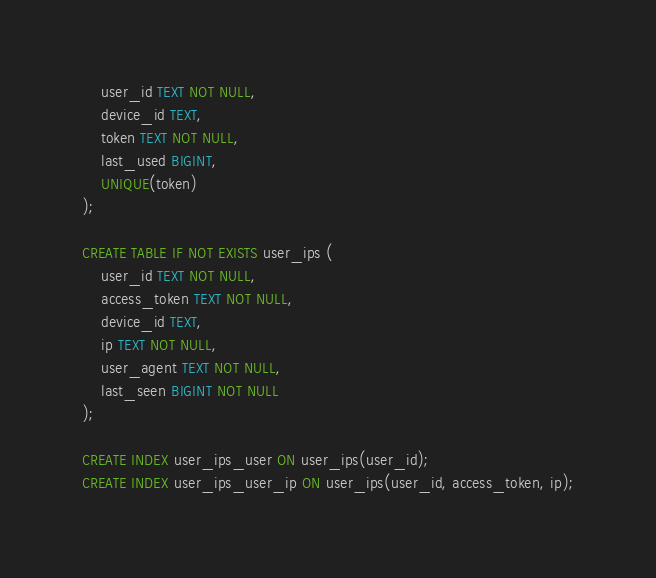Convert code to text. <code><loc_0><loc_0><loc_500><loc_500><_SQL_>    user_id TEXT NOT NULL,
    device_id TEXT,
    token TEXT NOT NULL,
    last_used BIGINT,
    UNIQUE(token)
);

CREATE TABLE IF NOT EXISTS user_ips (
    user_id TEXT NOT NULL,
    access_token TEXT NOT NULL,
    device_id TEXT,
    ip TEXT NOT NULL,
    user_agent TEXT NOT NULL,
    last_seen BIGINT NOT NULL
);

CREATE INDEX user_ips_user ON user_ips(user_id);
CREATE INDEX user_ips_user_ip ON user_ips(user_id, access_token, ip);
</code> 